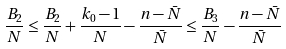Convert formula to latex. <formula><loc_0><loc_0><loc_500><loc_500>\frac { B _ { 2 } } { N } \leq \frac { B _ { 2 } } { N } + \frac { k _ { 0 } - 1 } { N } - \frac { n - \bar { N } } { \bar { N } } \leq \frac { B _ { 3 } } { N } - \frac { n - \bar { N } } { \bar { N } }</formula> 